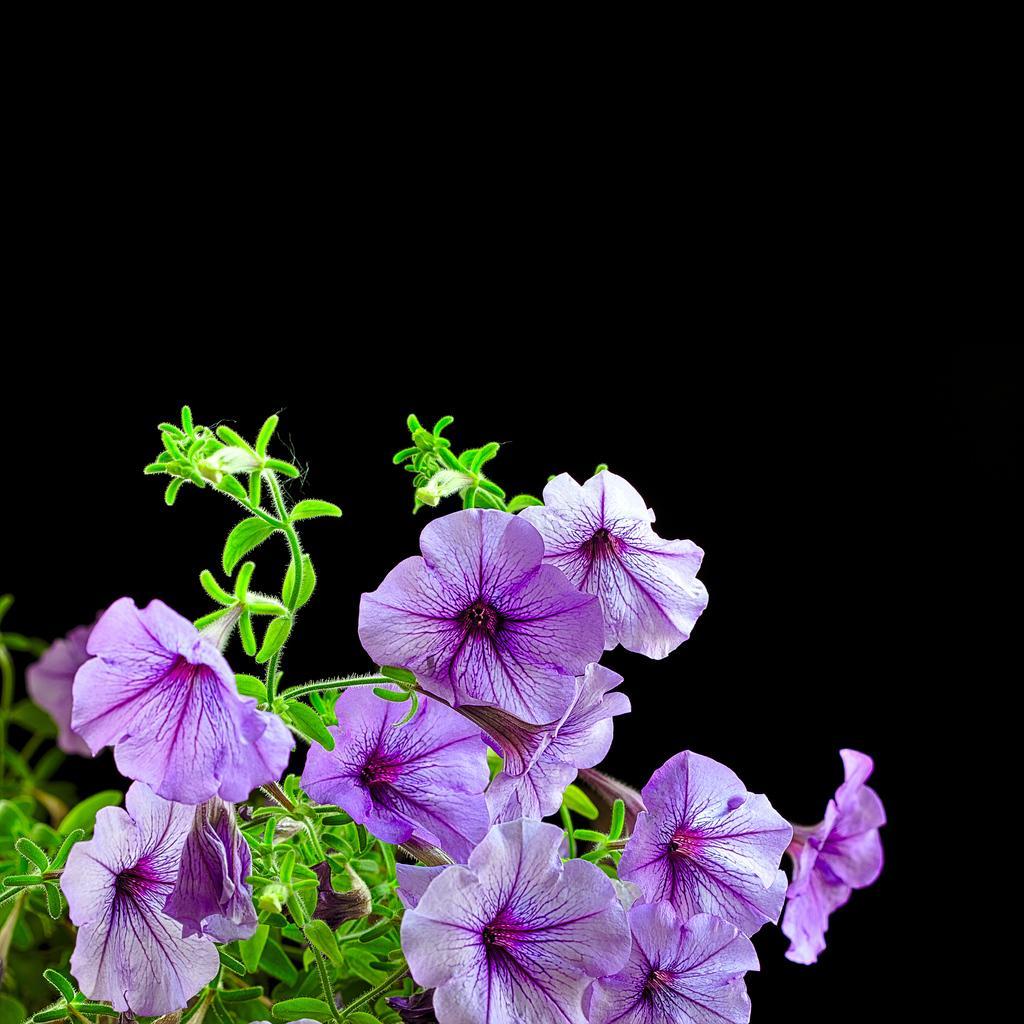Could you give a brief overview of what you see in this image? In this image I can see on the left side there are flowers in brinjal color and there are plants in green color. 